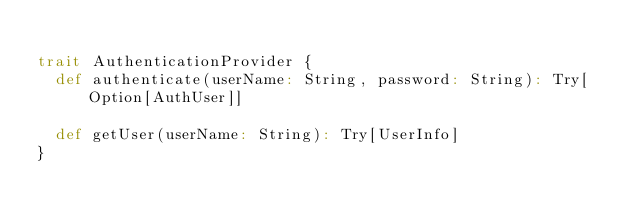<code> <loc_0><loc_0><loc_500><loc_500><_Scala_>
trait AuthenticationProvider {
  def authenticate(userName: String, password: String): Try[Option[AuthUser]]

  def getUser(userName: String): Try[UserInfo]
}
</code> 